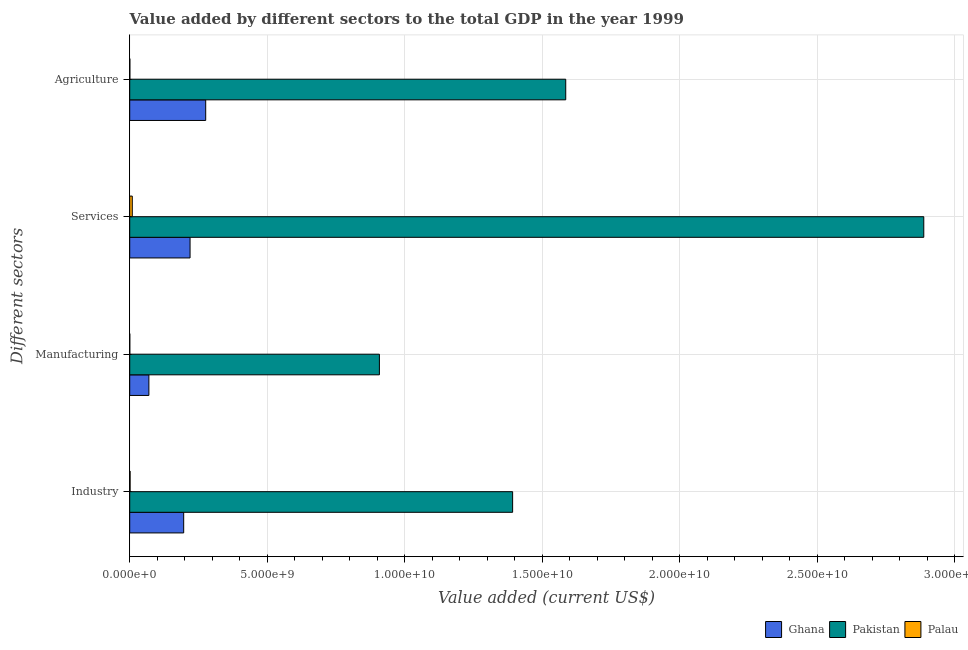Are the number of bars per tick equal to the number of legend labels?
Offer a very short reply. Yes. Are the number of bars on each tick of the Y-axis equal?
Your response must be concise. Yes. How many bars are there on the 1st tick from the top?
Keep it short and to the point. 3. How many bars are there on the 3rd tick from the bottom?
Keep it short and to the point. 3. What is the label of the 2nd group of bars from the top?
Offer a terse response. Services. What is the value added by agricultural sector in Ghana?
Your response must be concise. 2.76e+09. Across all countries, what is the maximum value added by services sector?
Provide a succinct answer. 2.89e+1. Across all countries, what is the minimum value added by agricultural sector?
Provide a short and direct response. 4.51e+06. In which country was the value added by manufacturing sector maximum?
Keep it short and to the point. Pakistan. In which country was the value added by manufacturing sector minimum?
Offer a very short reply. Palau. What is the total value added by services sector in the graph?
Provide a short and direct response. 3.12e+1. What is the difference between the value added by services sector in Palau and that in Ghana?
Ensure brevity in your answer.  -2.10e+09. What is the difference between the value added by industrial sector in Ghana and the value added by agricultural sector in Pakistan?
Ensure brevity in your answer.  -1.39e+1. What is the average value added by manufacturing sector per country?
Provide a short and direct response. 3.26e+09. What is the difference between the value added by industrial sector and value added by services sector in Palau?
Offer a terse response. -7.95e+07. In how many countries, is the value added by industrial sector greater than 5000000000 US$?
Make the answer very short. 1. What is the ratio of the value added by services sector in Pakistan to that in Ghana?
Ensure brevity in your answer.  13.16. What is the difference between the highest and the second highest value added by manufacturing sector?
Your response must be concise. 8.38e+09. What is the difference between the highest and the lowest value added by industrial sector?
Make the answer very short. 1.39e+1. In how many countries, is the value added by agricultural sector greater than the average value added by agricultural sector taken over all countries?
Offer a terse response. 1. Is the sum of the value added by agricultural sector in Pakistan and Palau greater than the maximum value added by manufacturing sector across all countries?
Provide a succinct answer. Yes. Is it the case that in every country, the sum of the value added by services sector and value added by agricultural sector is greater than the sum of value added by manufacturing sector and value added by industrial sector?
Give a very brief answer. No. What does the 3rd bar from the bottom in Industry represents?
Provide a short and direct response. Palau. How many bars are there?
Provide a short and direct response. 12. Are all the bars in the graph horizontal?
Your answer should be very brief. Yes. Where does the legend appear in the graph?
Offer a very short reply. Bottom right. What is the title of the graph?
Offer a terse response. Value added by different sectors to the total GDP in the year 1999. What is the label or title of the X-axis?
Make the answer very short. Value added (current US$). What is the label or title of the Y-axis?
Provide a succinct answer. Different sectors. What is the Value added (current US$) in Ghana in Industry?
Make the answer very short. 1.96e+09. What is the Value added (current US$) of Pakistan in Industry?
Offer a very short reply. 1.39e+1. What is the Value added (current US$) in Palau in Industry?
Your answer should be compact. 1.35e+07. What is the Value added (current US$) in Ghana in Manufacturing?
Give a very brief answer. 6.97e+08. What is the Value added (current US$) of Pakistan in Manufacturing?
Ensure brevity in your answer.  9.08e+09. What is the Value added (current US$) in Palau in Manufacturing?
Provide a short and direct response. 1.61e+06. What is the Value added (current US$) of Ghana in Services?
Your answer should be compact. 2.19e+09. What is the Value added (current US$) in Pakistan in Services?
Give a very brief answer. 2.89e+1. What is the Value added (current US$) in Palau in Services?
Provide a succinct answer. 9.29e+07. What is the Value added (current US$) in Ghana in Agriculture?
Offer a terse response. 2.76e+09. What is the Value added (current US$) of Pakistan in Agriculture?
Make the answer very short. 1.59e+1. What is the Value added (current US$) of Palau in Agriculture?
Provide a succinct answer. 4.51e+06. Across all Different sectors, what is the maximum Value added (current US$) in Ghana?
Make the answer very short. 2.76e+09. Across all Different sectors, what is the maximum Value added (current US$) in Pakistan?
Your response must be concise. 2.89e+1. Across all Different sectors, what is the maximum Value added (current US$) in Palau?
Provide a short and direct response. 9.29e+07. Across all Different sectors, what is the minimum Value added (current US$) of Ghana?
Your answer should be very brief. 6.97e+08. Across all Different sectors, what is the minimum Value added (current US$) in Pakistan?
Make the answer very short. 9.08e+09. Across all Different sectors, what is the minimum Value added (current US$) in Palau?
Your answer should be compact. 1.61e+06. What is the total Value added (current US$) of Ghana in the graph?
Your answer should be very brief. 7.61e+09. What is the total Value added (current US$) in Pakistan in the graph?
Keep it short and to the point. 6.77e+1. What is the total Value added (current US$) in Palau in the graph?
Keep it short and to the point. 1.13e+08. What is the difference between the Value added (current US$) of Ghana in Industry and that in Manufacturing?
Make the answer very short. 1.27e+09. What is the difference between the Value added (current US$) in Pakistan in Industry and that in Manufacturing?
Offer a terse response. 4.84e+09. What is the difference between the Value added (current US$) in Palau in Industry and that in Manufacturing?
Your response must be concise. 1.19e+07. What is the difference between the Value added (current US$) of Ghana in Industry and that in Services?
Offer a terse response. -2.32e+08. What is the difference between the Value added (current US$) in Pakistan in Industry and that in Services?
Keep it short and to the point. -1.49e+1. What is the difference between the Value added (current US$) of Palau in Industry and that in Services?
Offer a very short reply. -7.95e+07. What is the difference between the Value added (current US$) of Ghana in Industry and that in Agriculture?
Make the answer very short. -8.00e+08. What is the difference between the Value added (current US$) in Pakistan in Industry and that in Agriculture?
Your response must be concise. -1.93e+09. What is the difference between the Value added (current US$) of Palau in Industry and that in Agriculture?
Provide a short and direct response. 8.96e+06. What is the difference between the Value added (current US$) of Ghana in Manufacturing and that in Services?
Make the answer very short. -1.50e+09. What is the difference between the Value added (current US$) in Pakistan in Manufacturing and that in Services?
Provide a short and direct response. -1.98e+1. What is the difference between the Value added (current US$) of Palau in Manufacturing and that in Services?
Offer a terse response. -9.13e+07. What is the difference between the Value added (current US$) of Ghana in Manufacturing and that in Agriculture?
Keep it short and to the point. -2.07e+09. What is the difference between the Value added (current US$) of Pakistan in Manufacturing and that in Agriculture?
Your response must be concise. -6.77e+09. What is the difference between the Value added (current US$) of Palau in Manufacturing and that in Agriculture?
Make the answer very short. -2.90e+06. What is the difference between the Value added (current US$) of Ghana in Services and that in Agriculture?
Offer a very short reply. -5.68e+08. What is the difference between the Value added (current US$) in Pakistan in Services and that in Agriculture?
Make the answer very short. 1.30e+1. What is the difference between the Value added (current US$) of Palau in Services and that in Agriculture?
Your answer should be very brief. 8.84e+07. What is the difference between the Value added (current US$) in Ghana in Industry and the Value added (current US$) in Pakistan in Manufacturing?
Your response must be concise. -7.12e+09. What is the difference between the Value added (current US$) of Ghana in Industry and the Value added (current US$) of Palau in Manufacturing?
Your response must be concise. 1.96e+09. What is the difference between the Value added (current US$) in Pakistan in Industry and the Value added (current US$) in Palau in Manufacturing?
Your answer should be compact. 1.39e+1. What is the difference between the Value added (current US$) of Ghana in Industry and the Value added (current US$) of Pakistan in Services?
Your answer should be very brief. -2.69e+1. What is the difference between the Value added (current US$) of Ghana in Industry and the Value added (current US$) of Palau in Services?
Give a very brief answer. 1.87e+09. What is the difference between the Value added (current US$) of Pakistan in Industry and the Value added (current US$) of Palau in Services?
Ensure brevity in your answer.  1.38e+1. What is the difference between the Value added (current US$) of Ghana in Industry and the Value added (current US$) of Pakistan in Agriculture?
Provide a short and direct response. -1.39e+1. What is the difference between the Value added (current US$) in Ghana in Industry and the Value added (current US$) in Palau in Agriculture?
Your answer should be compact. 1.96e+09. What is the difference between the Value added (current US$) in Pakistan in Industry and the Value added (current US$) in Palau in Agriculture?
Your answer should be very brief. 1.39e+1. What is the difference between the Value added (current US$) of Ghana in Manufacturing and the Value added (current US$) of Pakistan in Services?
Make the answer very short. -2.82e+1. What is the difference between the Value added (current US$) of Ghana in Manufacturing and the Value added (current US$) of Palau in Services?
Your response must be concise. 6.04e+08. What is the difference between the Value added (current US$) of Pakistan in Manufacturing and the Value added (current US$) of Palau in Services?
Ensure brevity in your answer.  8.98e+09. What is the difference between the Value added (current US$) in Ghana in Manufacturing and the Value added (current US$) in Pakistan in Agriculture?
Your answer should be compact. -1.52e+1. What is the difference between the Value added (current US$) in Ghana in Manufacturing and the Value added (current US$) in Palau in Agriculture?
Ensure brevity in your answer.  6.92e+08. What is the difference between the Value added (current US$) in Pakistan in Manufacturing and the Value added (current US$) in Palau in Agriculture?
Ensure brevity in your answer.  9.07e+09. What is the difference between the Value added (current US$) of Ghana in Services and the Value added (current US$) of Pakistan in Agriculture?
Provide a succinct answer. -1.37e+1. What is the difference between the Value added (current US$) of Ghana in Services and the Value added (current US$) of Palau in Agriculture?
Your answer should be compact. 2.19e+09. What is the difference between the Value added (current US$) in Pakistan in Services and the Value added (current US$) in Palau in Agriculture?
Your answer should be very brief. 2.89e+1. What is the average Value added (current US$) in Ghana per Different sectors?
Provide a succinct answer. 1.90e+09. What is the average Value added (current US$) of Pakistan per Different sectors?
Offer a terse response. 1.69e+1. What is the average Value added (current US$) of Palau per Different sectors?
Make the answer very short. 2.81e+07. What is the difference between the Value added (current US$) of Ghana and Value added (current US$) of Pakistan in Industry?
Your answer should be very brief. -1.20e+1. What is the difference between the Value added (current US$) of Ghana and Value added (current US$) of Palau in Industry?
Provide a succinct answer. 1.95e+09. What is the difference between the Value added (current US$) of Pakistan and Value added (current US$) of Palau in Industry?
Keep it short and to the point. 1.39e+1. What is the difference between the Value added (current US$) in Ghana and Value added (current US$) in Pakistan in Manufacturing?
Give a very brief answer. -8.38e+09. What is the difference between the Value added (current US$) in Ghana and Value added (current US$) in Palau in Manufacturing?
Offer a terse response. 6.95e+08. What is the difference between the Value added (current US$) in Pakistan and Value added (current US$) in Palau in Manufacturing?
Your answer should be compact. 9.08e+09. What is the difference between the Value added (current US$) in Ghana and Value added (current US$) in Pakistan in Services?
Your answer should be compact. -2.67e+1. What is the difference between the Value added (current US$) of Ghana and Value added (current US$) of Palau in Services?
Your answer should be very brief. 2.10e+09. What is the difference between the Value added (current US$) of Pakistan and Value added (current US$) of Palau in Services?
Give a very brief answer. 2.88e+1. What is the difference between the Value added (current US$) of Ghana and Value added (current US$) of Pakistan in Agriculture?
Your answer should be compact. -1.31e+1. What is the difference between the Value added (current US$) of Ghana and Value added (current US$) of Palau in Agriculture?
Your response must be concise. 2.76e+09. What is the difference between the Value added (current US$) of Pakistan and Value added (current US$) of Palau in Agriculture?
Keep it short and to the point. 1.58e+1. What is the ratio of the Value added (current US$) of Ghana in Industry to that in Manufacturing?
Offer a very short reply. 2.82. What is the ratio of the Value added (current US$) of Pakistan in Industry to that in Manufacturing?
Provide a short and direct response. 1.53. What is the ratio of the Value added (current US$) of Palau in Industry to that in Manufacturing?
Your response must be concise. 8.37. What is the ratio of the Value added (current US$) in Ghana in Industry to that in Services?
Ensure brevity in your answer.  0.89. What is the ratio of the Value added (current US$) of Pakistan in Industry to that in Services?
Your response must be concise. 0.48. What is the ratio of the Value added (current US$) of Palau in Industry to that in Services?
Give a very brief answer. 0.14. What is the ratio of the Value added (current US$) of Ghana in Industry to that in Agriculture?
Your answer should be compact. 0.71. What is the ratio of the Value added (current US$) of Pakistan in Industry to that in Agriculture?
Ensure brevity in your answer.  0.88. What is the ratio of the Value added (current US$) of Palau in Industry to that in Agriculture?
Provide a succinct answer. 2.99. What is the ratio of the Value added (current US$) in Ghana in Manufacturing to that in Services?
Your answer should be compact. 0.32. What is the ratio of the Value added (current US$) of Pakistan in Manufacturing to that in Services?
Offer a very short reply. 0.31. What is the ratio of the Value added (current US$) of Palau in Manufacturing to that in Services?
Your response must be concise. 0.02. What is the ratio of the Value added (current US$) in Ghana in Manufacturing to that in Agriculture?
Keep it short and to the point. 0.25. What is the ratio of the Value added (current US$) in Pakistan in Manufacturing to that in Agriculture?
Offer a terse response. 0.57. What is the ratio of the Value added (current US$) in Palau in Manufacturing to that in Agriculture?
Keep it short and to the point. 0.36. What is the ratio of the Value added (current US$) in Ghana in Services to that in Agriculture?
Offer a very short reply. 0.79. What is the ratio of the Value added (current US$) of Pakistan in Services to that in Agriculture?
Ensure brevity in your answer.  1.82. What is the ratio of the Value added (current US$) in Palau in Services to that in Agriculture?
Your answer should be compact. 20.62. What is the difference between the highest and the second highest Value added (current US$) in Ghana?
Offer a very short reply. 5.68e+08. What is the difference between the highest and the second highest Value added (current US$) of Pakistan?
Offer a very short reply. 1.30e+1. What is the difference between the highest and the second highest Value added (current US$) in Palau?
Your answer should be very brief. 7.95e+07. What is the difference between the highest and the lowest Value added (current US$) in Ghana?
Make the answer very short. 2.07e+09. What is the difference between the highest and the lowest Value added (current US$) in Pakistan?
Your answer should be very brief. 1.98e+1. What is the difference between the highest and the lowest Value added (current US$) in Palau?
Offer a very short reply. 9.13e+07. 